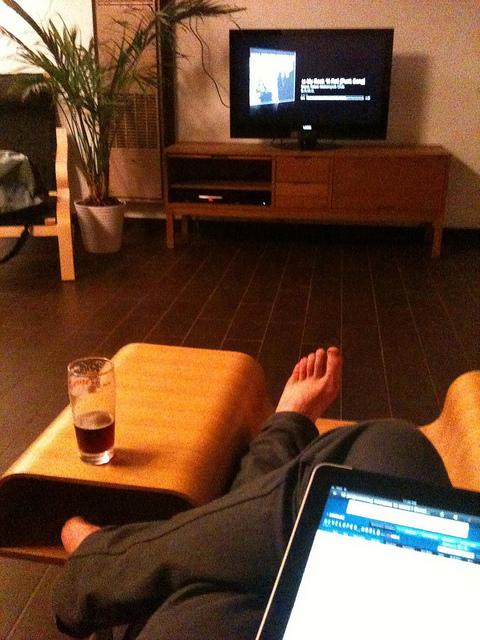How many screens are visible?
Quick response, please. 2. What item has a red light?
Concise answer only. Dvr. Is this person wearing socks?
Concise answer only. No. 